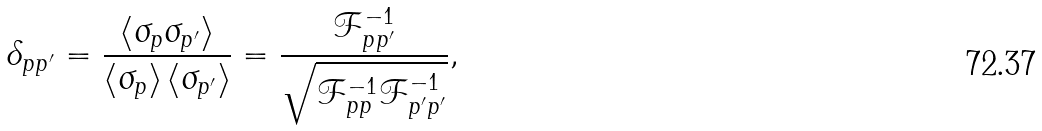<formula> <loc_0><loc_0><loc_500><loc_500>\delta _ { p p ^ { \prime } } = \frac { \langle \sigma _ { p } \sigma _ { p ^ { \prime } } \rangle } { \langle \sigma _ { p } \rangle \, \langle \sigma _ { p ^ { \prime } } \rangle } = \frac { \mathcal { F } ^ { - 1 } _ { p p ^ { \prime } } } { \sqrt { \mathcal { F } ^ { - 1 } _ { p p } \mathcal { F } ^ { - 1 } _ { p ^ { \prime } p ^ { \prime } } } } ,</formula> 